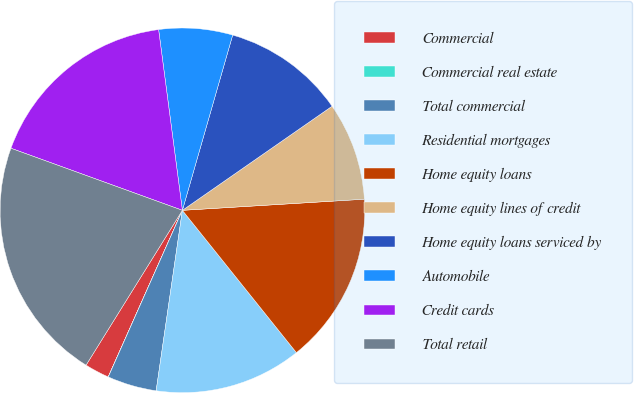Convert chart. <chart><loc_0><loc_0><loc_500><loc_500><pie_chart><fcel>Commercial<fcel>Commercial real estate<fcel>Total commercial<fcel>Residential mortgages<fcel>Home equity loans<fcel>Home equity lines of credit<fcel>Home equity loans serviced by<fcel>Automobile<fcel>Credit cards<fcel>Total retail<nl><fcel>2.19%<fcel>0.01%<fcel>4.36%<fcel>13.05%<fcel>15.22%<fcel>8.7%<fcel>10.88%<fcel>6.53%<fcel>17.39%<fcel>21.67%<nl></chart> 